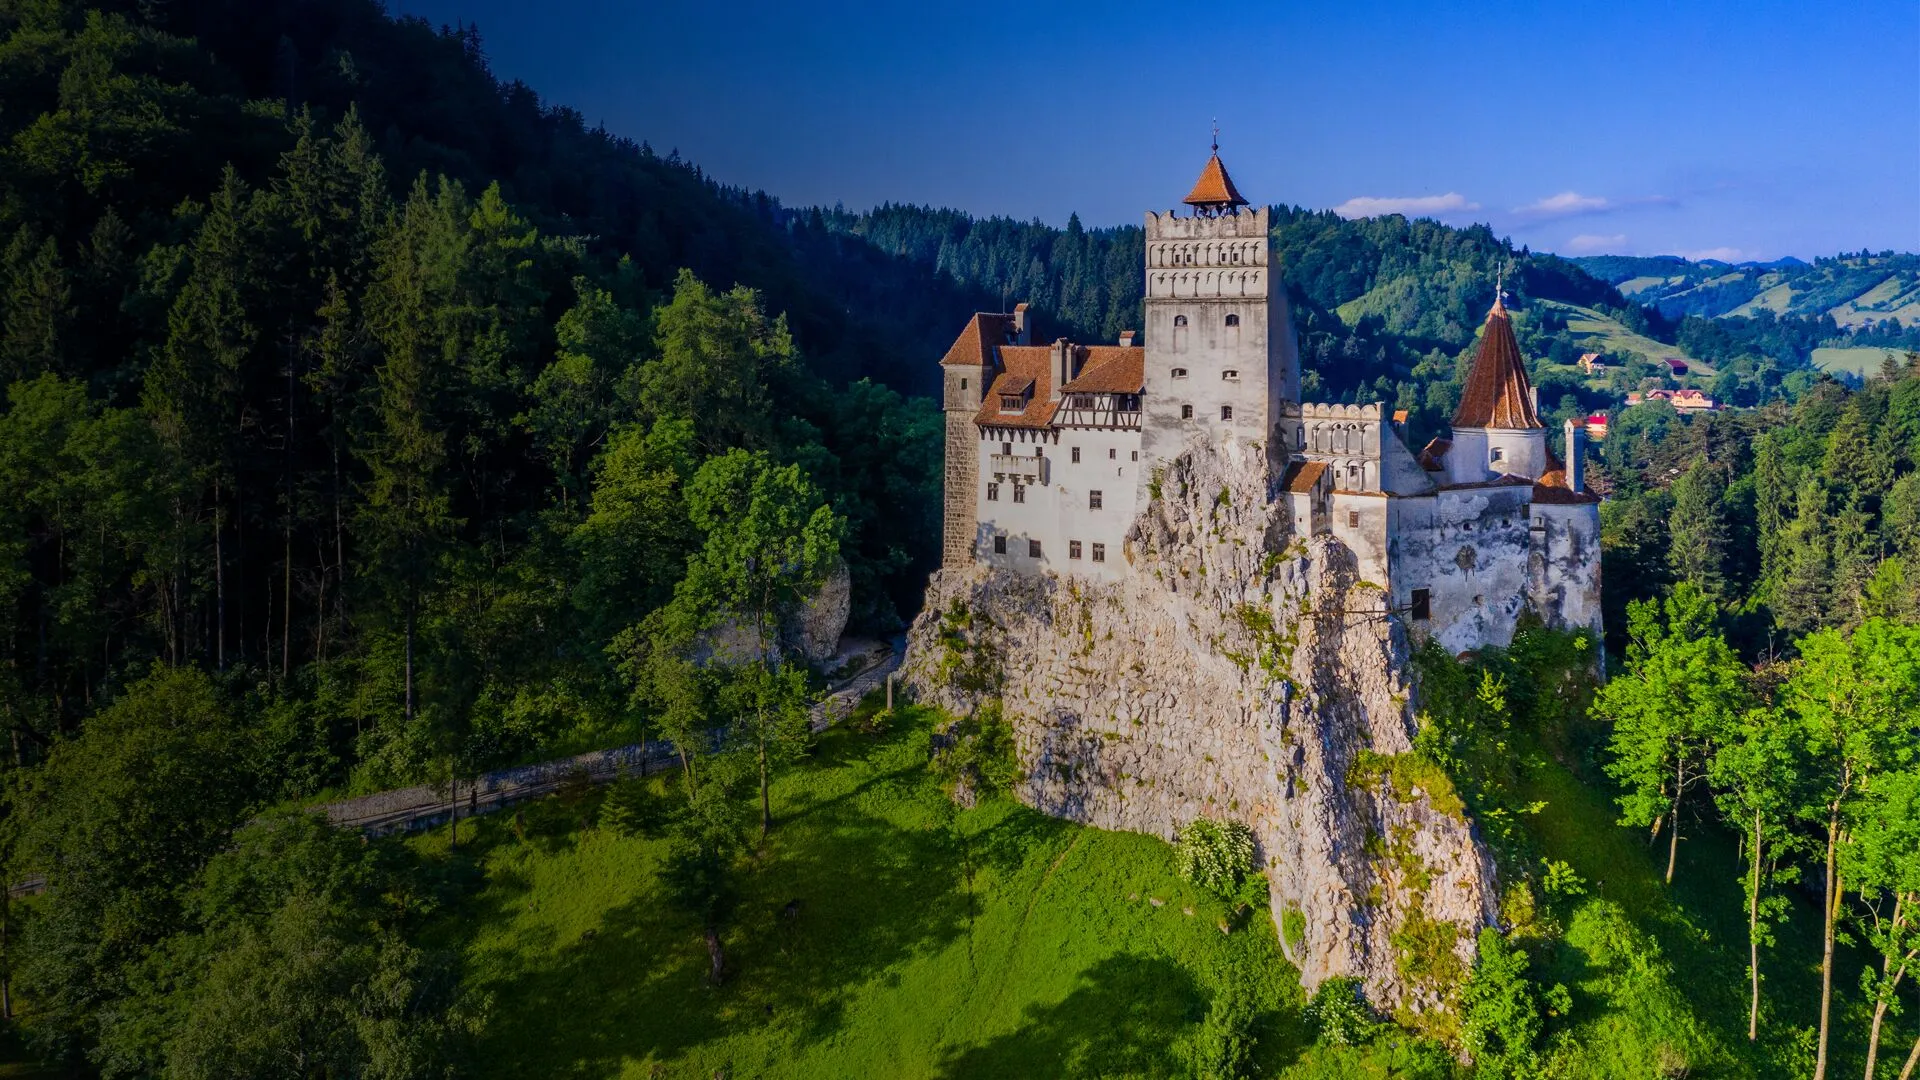What do you see happening in this image? The image captures the majestic Bran Castle, an iconic medieval fortress located in Romania. The castle is dramatically perched atop a rocky cliff, its white walls and orange-tiled roof contrasting beautifully with the lush greenery of the surrounding forest. With its tall tower and multiple turrets, the castle's intricate architecture stands out against the background of a clear blue sky. Bathed in the warm glow of sunlight, the panoramic view highlights the castle's strategic and picturesque location. Known for its historical significance and connections to the legend of Dracula, Bran Castle is a stunning landmark in this image. 